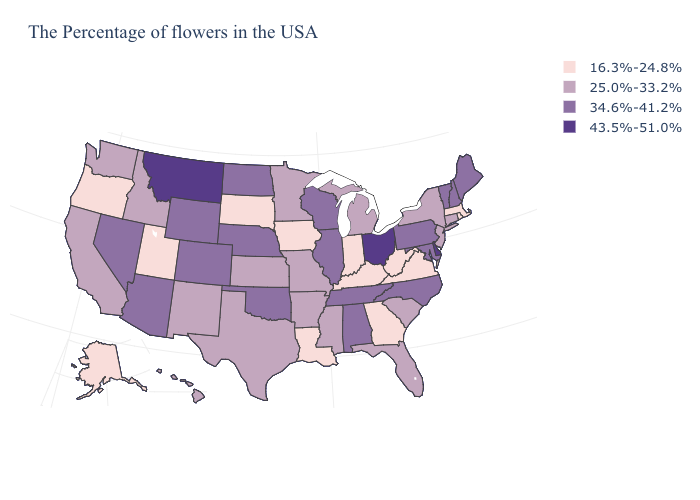Does Delaware have the highest value in the USA?
Concise answer only. Yes. Name the states that have a value in the range 25.0%-33.2%?
Give a very brief answer. Connecticut, New York, New Jersey, South Carolina, Florida, Michigan, Mississippi, Missouri, Arkansas, Minnesota, Kansas, Texas, New Mexico, Idaho, California, Washington, Hawaii. Does North Carolina have a lower value than Michigan?
Give a very brief answer. No. Name the states that have a value in the range 25.0%-33.2%?
Keep it brief. Connecticut, New York, New Jersey, South Carolina, Florida, Michigan, Mississippi, Missouri, Arkansas, Minnesota, Kansas, Texas, New Mexico, Idaho, California, Washington, Hawaii. Name the states that have a value in the range 34.6%-41.2%?
Short answer required. Maine, New Hampshire, Vermont, Maryland, Pennsylvania, North Carolina, Alabama, Tennessee, Wisconsin, Illinois, Nebraska, Oklahoma, North Dakota, Wyoming, Colorado, Arizona, Nevada. What is the lowest value in states that border Iowa?
Short answer required. 16.3%-24.8%. Name the states that have a value in the range 43.5%-51.0%?
Answer briefly. Delaware, Ohio, Montana. Name the states that have a value in the range 43.5%-51.0%?
Keep it brief. Delaware, Ohio, Montana. Among the states that border Georgia , does Alabama have the highest value?
Answer briefly. Yes. Among the states that border Indiana , does Illinois have the lowest value?
Keep it brief. No. Does South Dakota have the lowest value in the MidWest?
Keep it brief. Yes. What is the lowest value in the USA?
Be succinct. 16.3%-24.8%. What is the highest value in the USA?
Short answer required. 43.5%-51.0%. What is the highest value in the USA?
Answer briefly. 43.5%-51.0%. Does Pennsylvania have the same value as Texas?
Short answer required. No. 